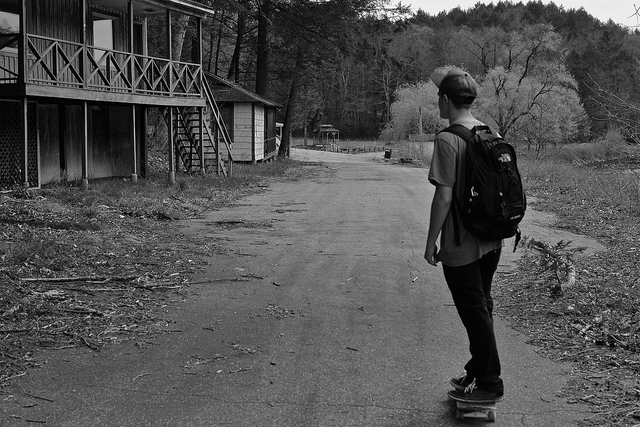<image>What color are the blooms? I don't know what color the blooms are. They could be gray, white, pink, or yellow. What is the man doing? It is ambiguous what the man is doing. He could be walking, skating, or skateboarding. What color are the blooms? I don't know what color the blooms are. It can be gray, white, pink, or yellow. What is the man doing? I don't know what the man is doing. He can be either walking, skating, skateboarding or standing. 